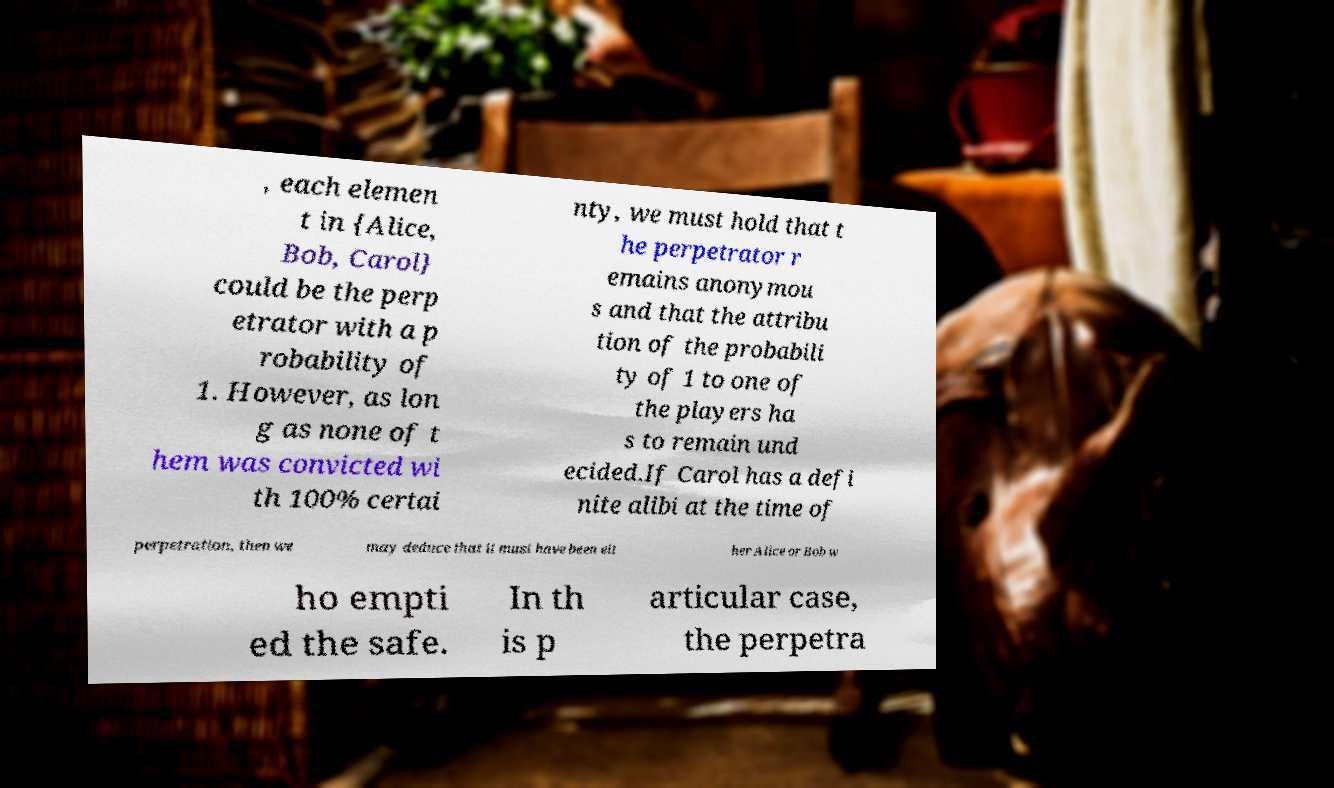Please identify and transcribe the text found in this image. , each elemen t in {Alice, Bob, Carol} could be the perp etrator with a p robability of 1. However, as lon g as none of t hem was convicted wi th 100% certai nty, we must hold that t he perpetrator r emains anonymou s and that the attribu tion of the probabili ty of 1 to one of the players ha s to remain und ecided.If Carol has a defi nite alibi at the time of perpetration, then we may deduce that it must have been eit her Alice or Bob w ho empti ed the safe. In th is p articular case, the perpetra 